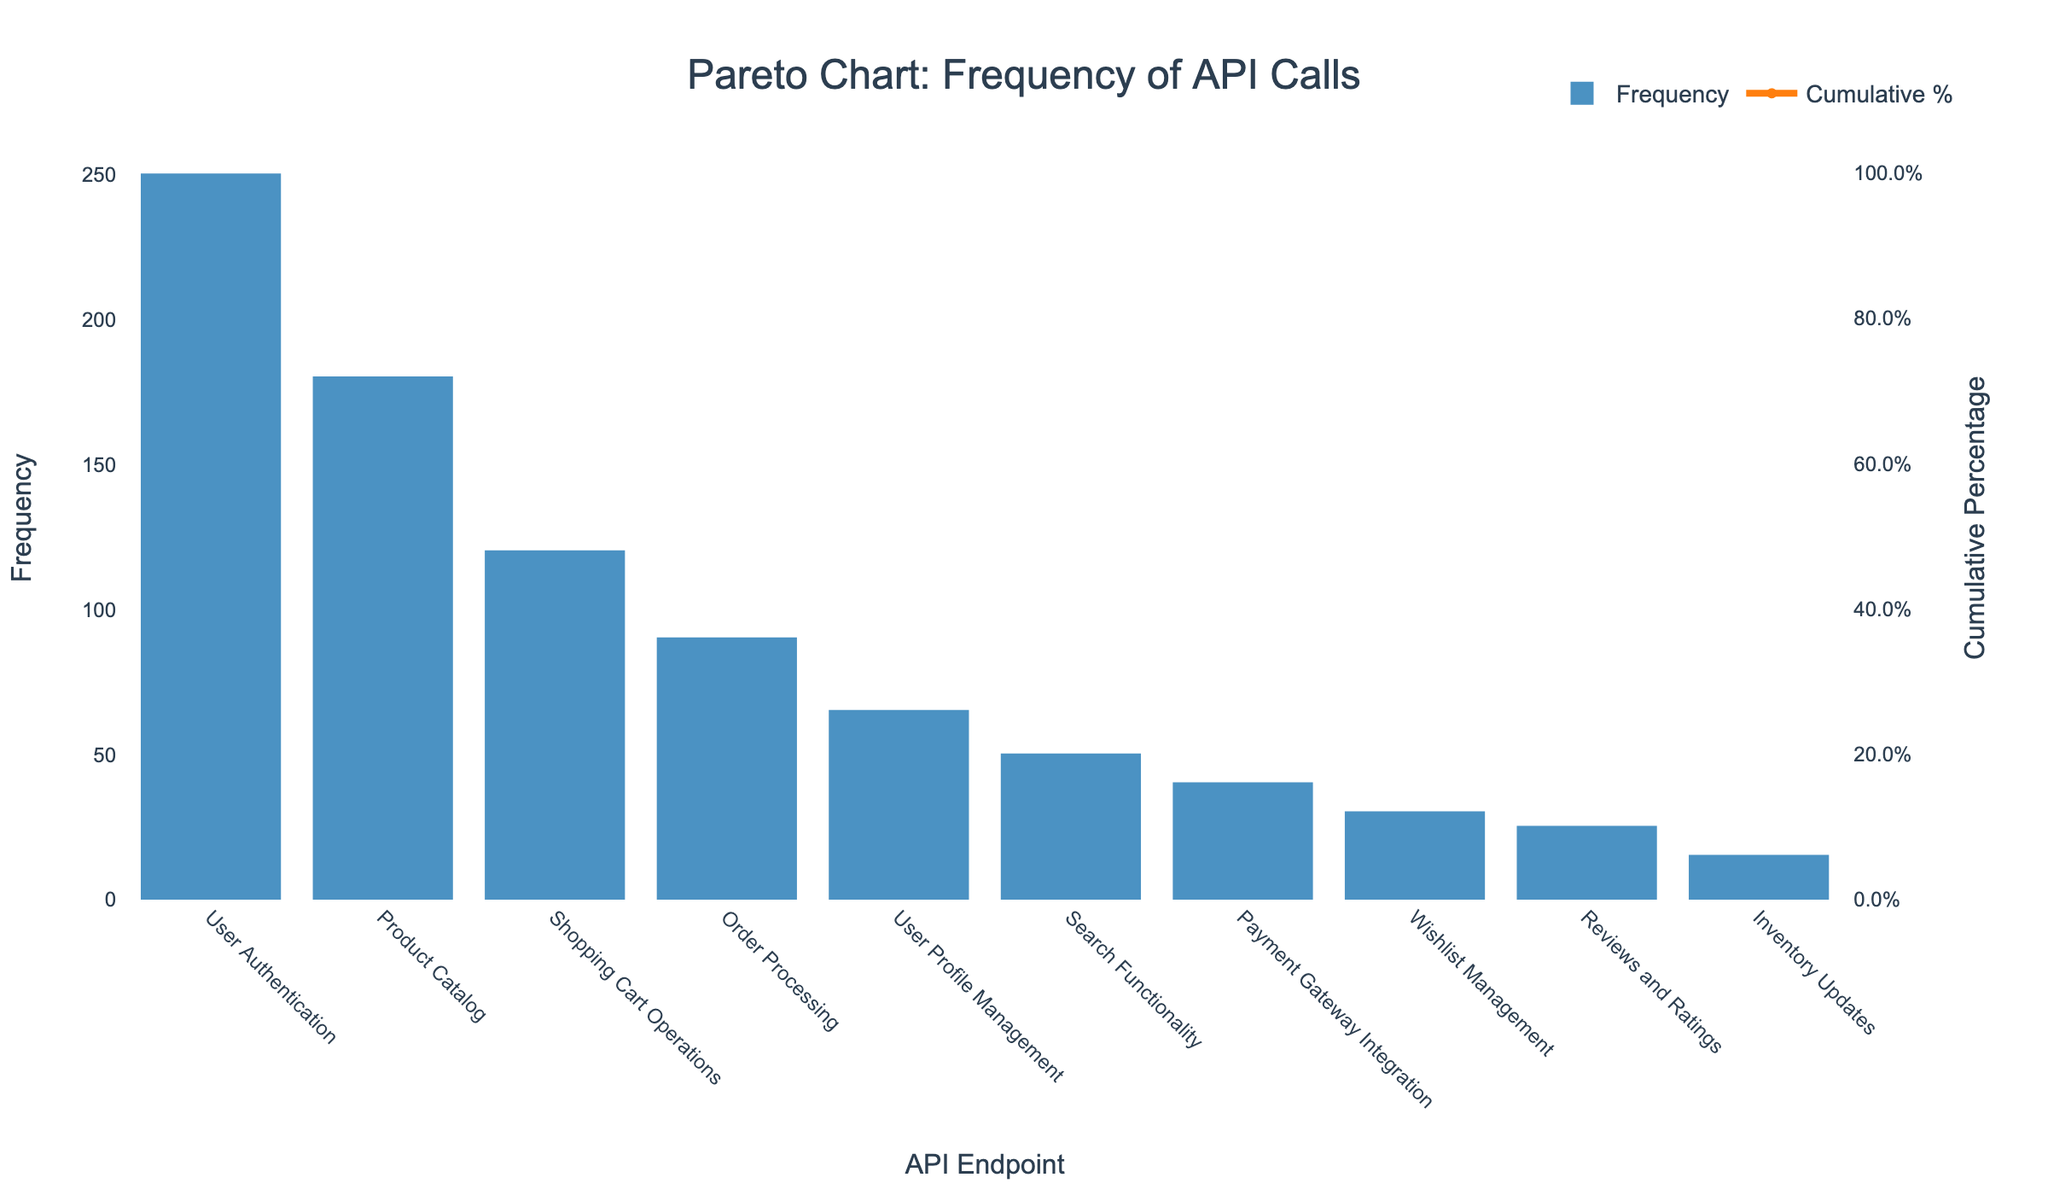What is the title of the Pareto chart? The title of the chart is located at the top center of the figure. It clearly states what is being represented within the chart.
Answer: Pareto Chart: Frequency of API Calls Which API endpoint has the highest frequency of calls? Locate the highest bar in the bar chart, which represents the API endpoint with the highest frequency.
Answer: User Authentication What is the cumulative percentage for "Product Catalog"? Find the 'Product Catalog' on the x-axis, then locate its corresponding point on the cumulative percentage line.
Answer: 49.7% How many API endpoints have a cumulative percentage greater than 90%? Look at the cumulative percentage line. Identify the data points that are above the 90% mark.
Answer: 3 What is the difference in frequency between the "User Authentication" and "User Profile Management" endpoints? Locate the bars for both endpoints. Subtract the frequency of "User Profile Management" from that of "User Authentication".
Answer: 185 Which endpoint has a lower frequency, "Order Processing" or "Reviews and Ratings"? Compare the heights of the bars for "Order Processing" and "Reviews and Ratings".
Answer: Reviews and Ratings What is the sum of the frequencies of the top three API endpoints? Add up the frequencies for the "User Authentication", "Product Catalog", and "Shopping Cart Operations" endpoints.
Answer: 550 What is the cumulative percentage corresponding to a frequency of 40? Locate the bar representing a frequency of 40 (Payment Gateway Integration), then find its corresponding point on the cumulative percentage line.
Answer: 91.9% Which endpoint contributes to reaching the 100% cumulative percentage? Identify the last point on the cumulative percentage line, indicating the endpoint that completes the 100%.
Answer: Inventory Updates What percentage of the total calls are made by the top two API endpoints? Add the frequencies of the top two endpoints, then divide by the total frequency of all endpoints and convert to percentage.
Answer: 49.7% 